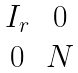<formula> <loc_0><loc_0><loc_500><loc_500>\begin{matrix} I _ { r } & 0 \\ 0 & N \end{matrix}</formula> 